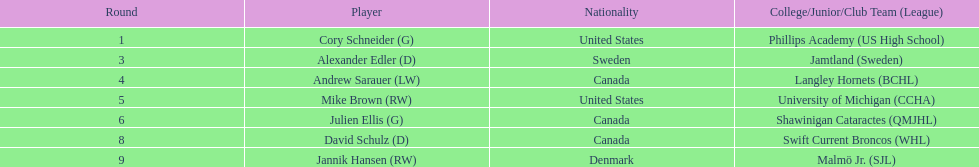What are the names of the colleges and jr leagues the players attended? Phillips Academy (US High School), Jamtland (Sweden), Langley Hornets (BCHL), University of Michigan (CCHA), Shawinigan Cataractes (QMJHL), Swift Current Broncos (WHL), Malmö Jr. (SJL). Which player played for the langley hornets? Andrew Sarauer (LW). 